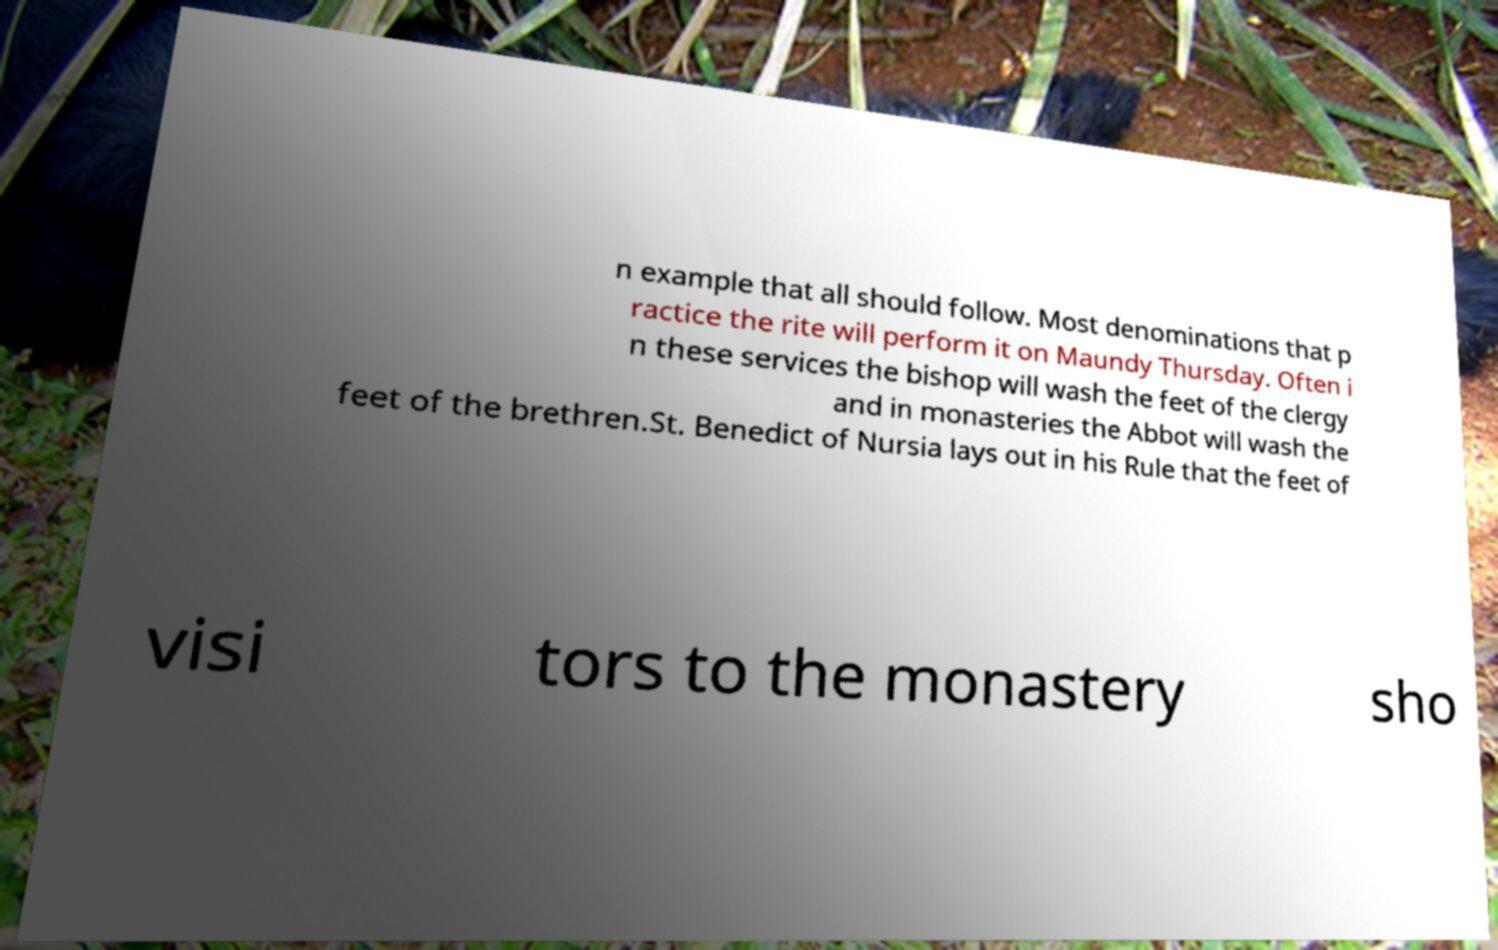What messages or text are displayed in this image? I need them in a readable, typed format. n example that all should follow. Most denominations that p ractice the rite will perform it on Maundy Thursday. Often i n these services the bishop will wash the feet of the clergy and in monasteries the Abbot will wash the feet of the brethren.St. Benedict of Nursia lays out in his Rule that the feet of visi tors to the monastery sho 